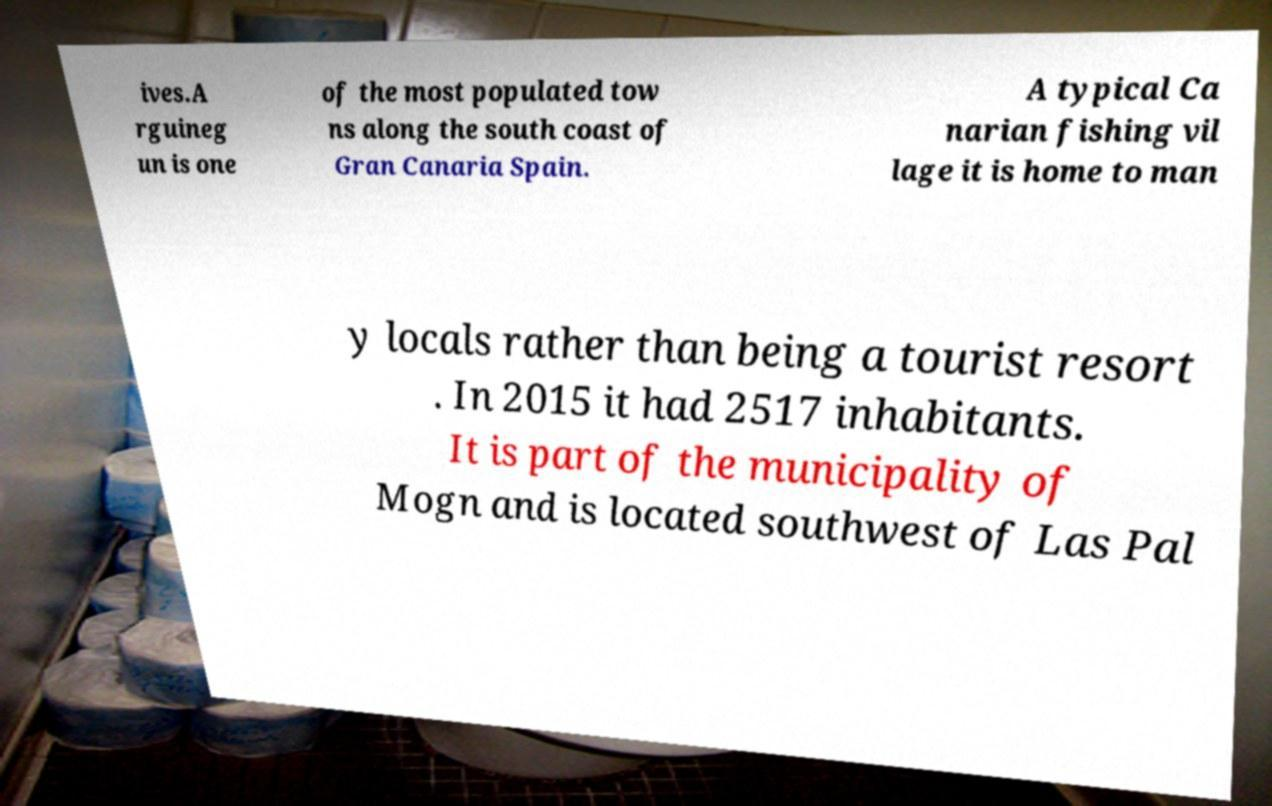Could you assist in decoding the text presented in this image and type it out clearly? ives.A rguineg un is one of the most populated tow ns along the south coast of Gran Canaria Spain. A typical Ca narian fishing vil lage it is home to man y locals rather than being a tourist resort . In 2015 it had 2517 inhabitants. It is part of the municipality of Mogn and is located southwest of Las Pal 